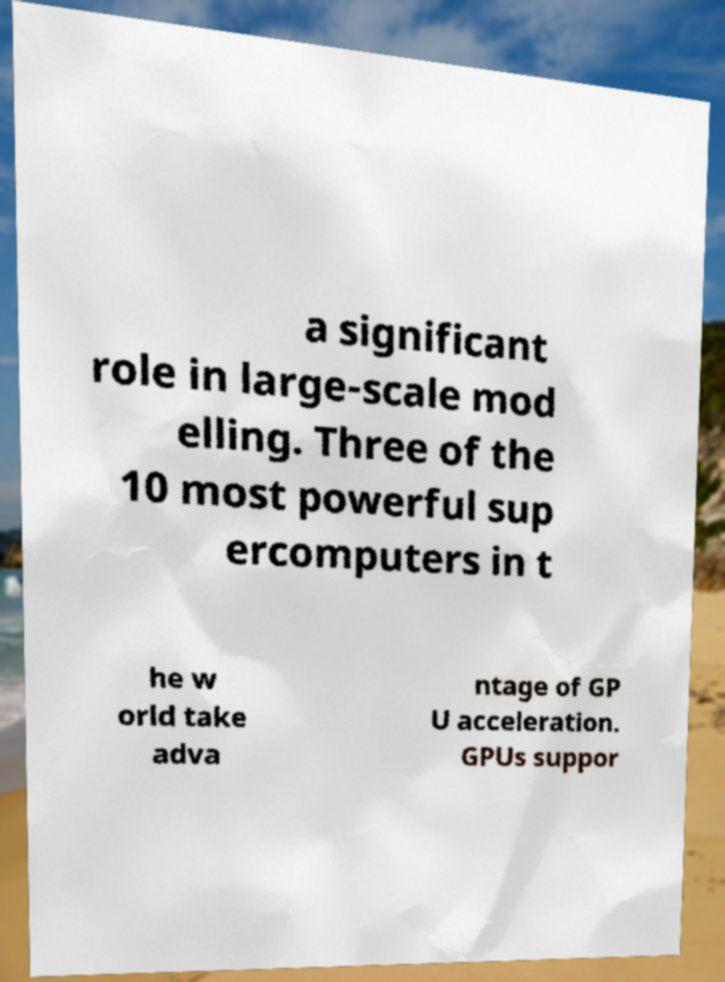Please identify and transcribe the text found in this image. a significant role in large-scale mod elling. Three of the 10 most powerful sup ercomputers in t he w orld take adva ntage of GP U acceleration. GPUs suppor 